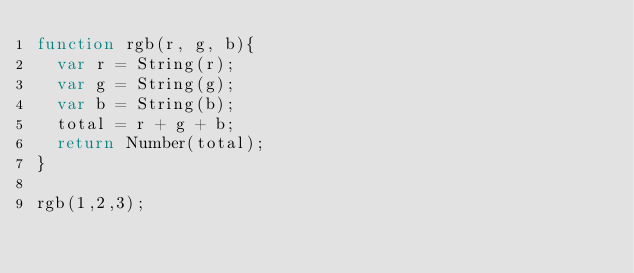Convert code to text. <code><loc_0><loc_0><loc_500><loc_500><_JavaScript_>function rgb(r, g, b){
  var r = String(r);
  var g = String(g);
  var b = String(b);
  total = r + g + b;
  return Number(total);
}

rgb(1,2,3);</code> 